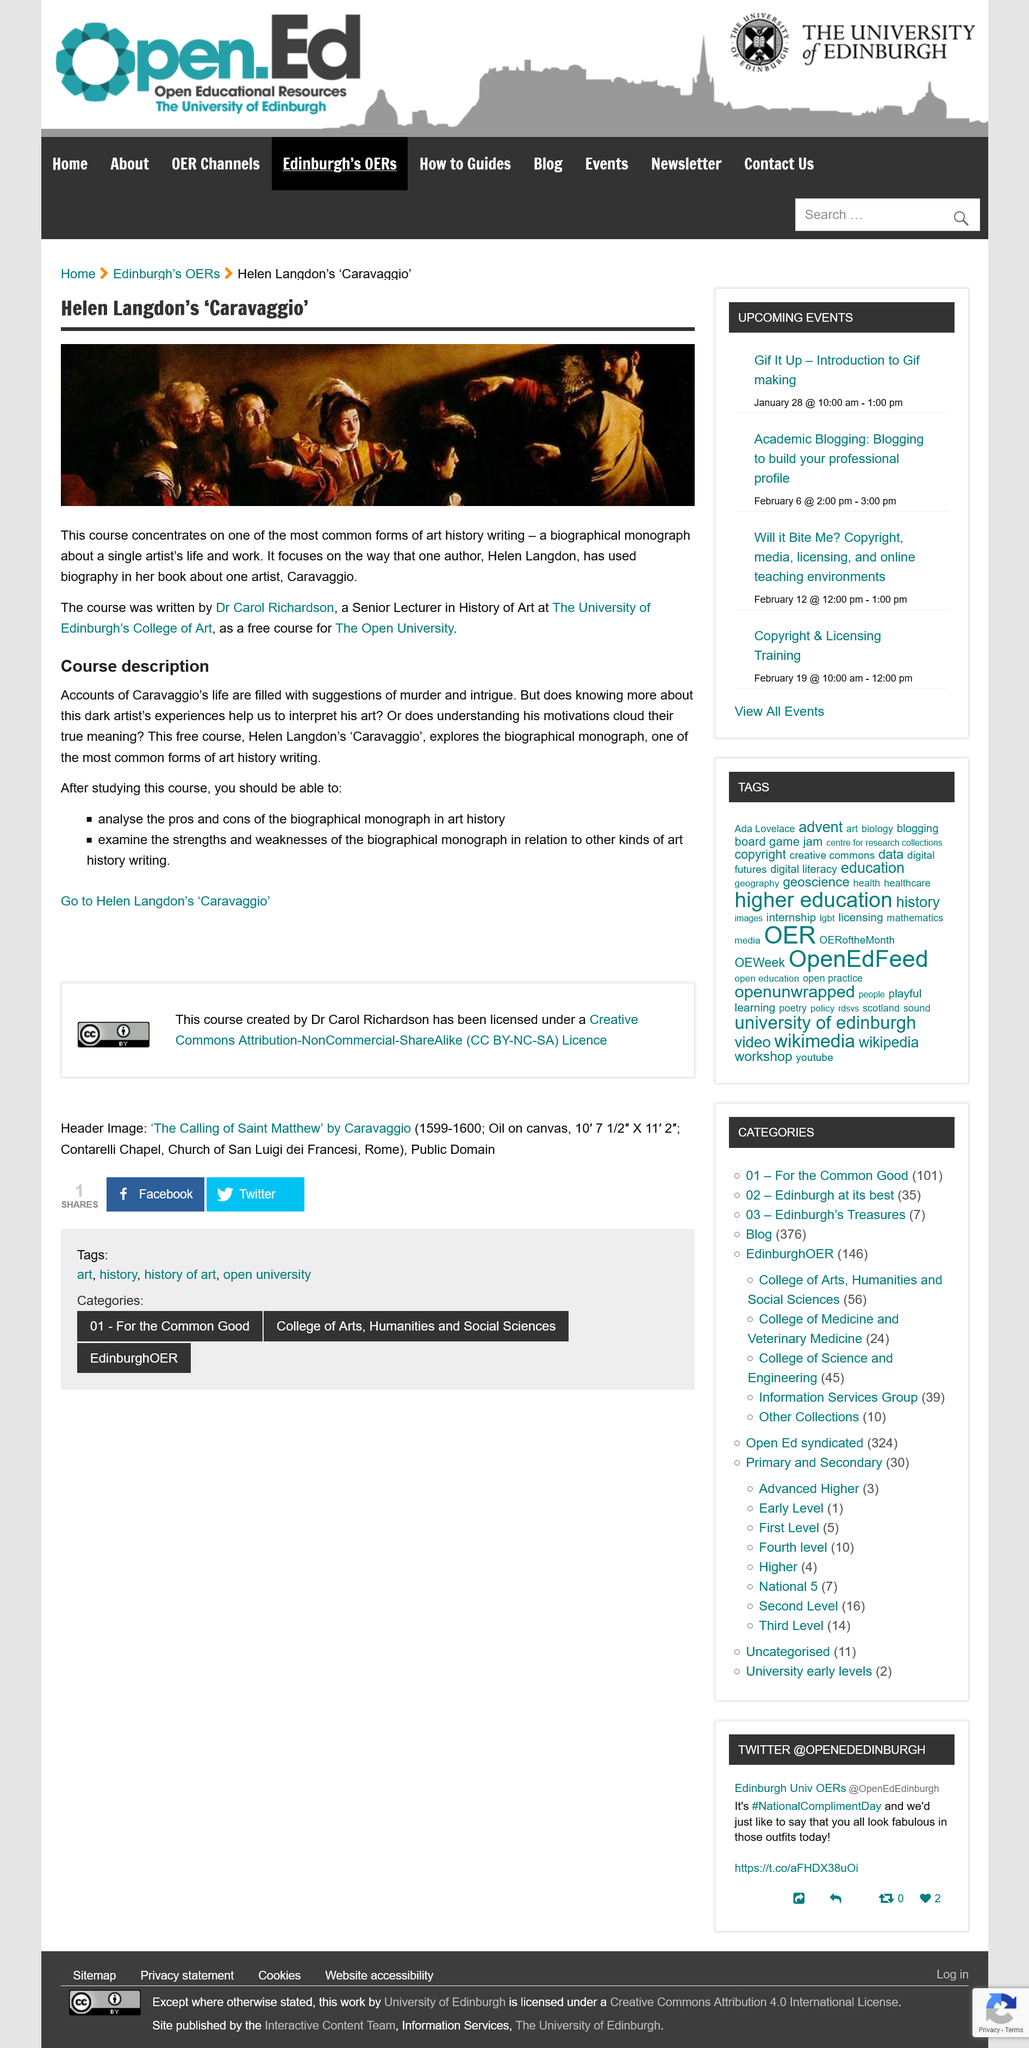Give some essential details in this illustration. After studying this course, students will be able to analyze the pros and cons of the biographical monograph in art history, examine the strengths and weaknesses of the biographical monograph in relation to other art history methods, and use this knowledge to inform their own research and analysis in the field. Dr. Carol Richardson wrote the course on Helen Langdon's "Caravaggio. Dr Carol Richardson is a Senior Lecturer in the History of Art at the University of Edinburgh's College of Art. The course description explores the Biographical monograph and delves into the exploration of a particular person's life. The accounts of Caravaggio's life were filled with suggestions of murder and intrigue. 